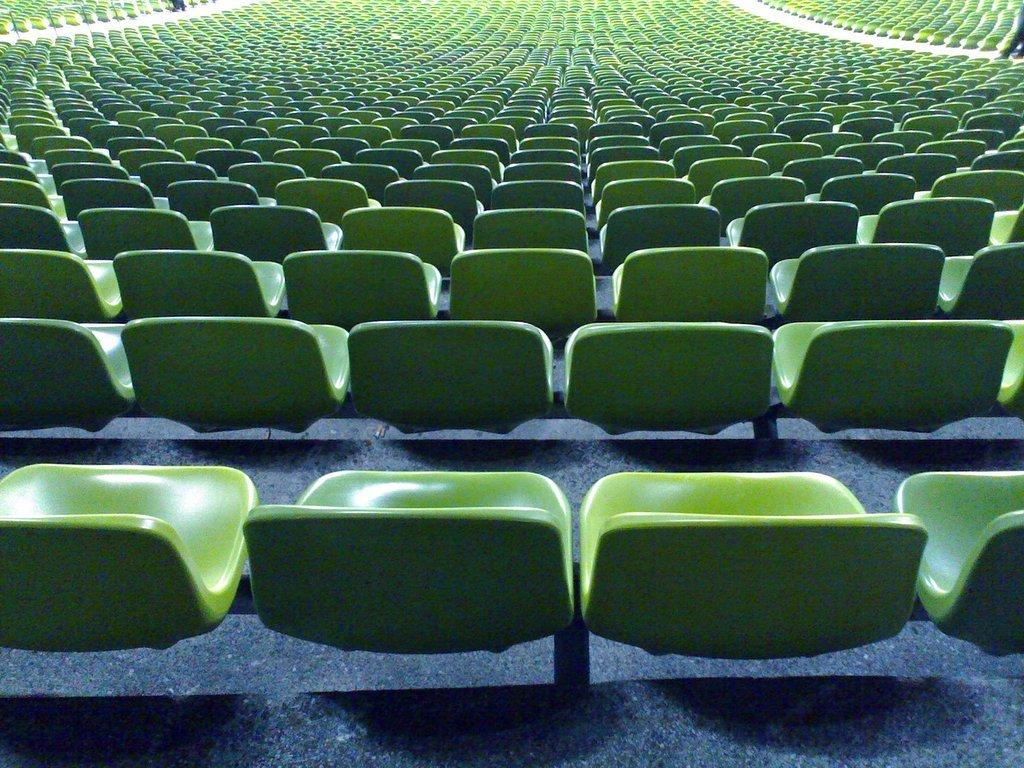What type of seating is present in the image? There are chairs in the image. Where are the chairs located? The chairs are in a stadium. How many chairs are visible in the image? There are a large number of chairs. What color are the chairs? The chairs are green in color. What type of poison is being used to limit the number of chairs in the image? There is no mention of poison or any limitation on the number of chairs in the image. The chairs are simply arranged in a stadium, and their color is green. 